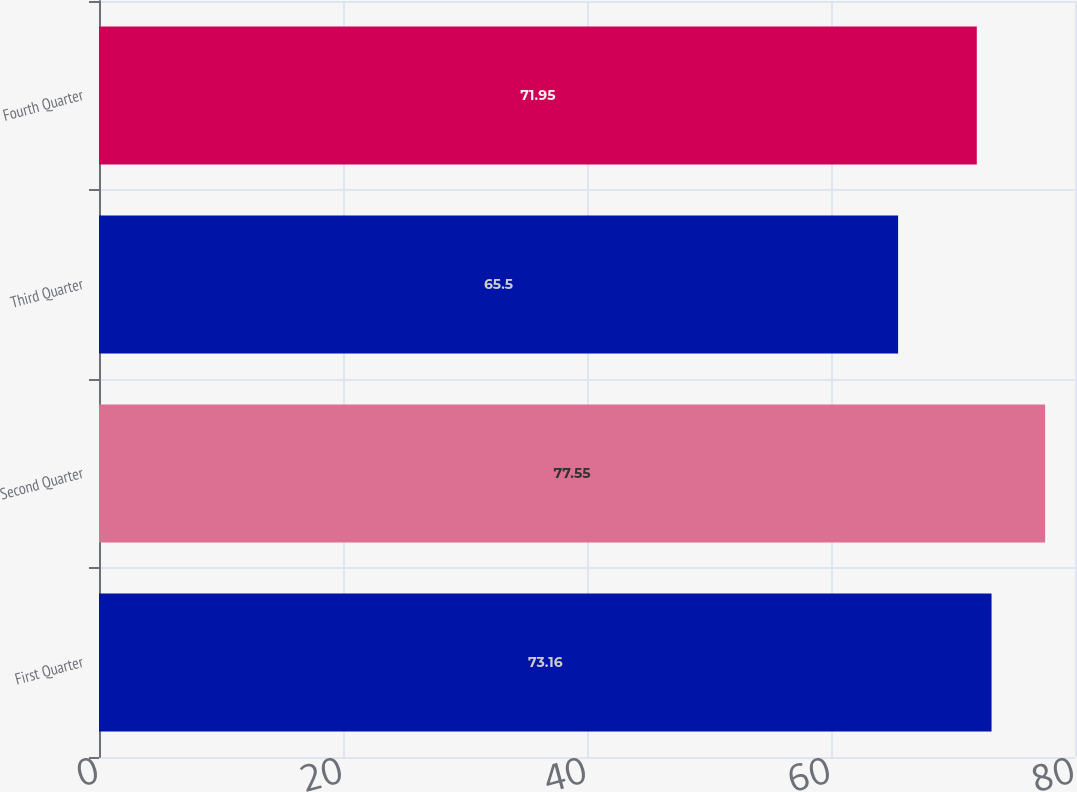Convert chart to OTSL. <chart><loc_0><loc_0><loc_500><loc_500><bar_chart><fcel>First Quarter<fcel>Second Quarter<fcel>Third Quarter<fcel>Fourth Quarter<nl><fcel>73.16<fcel>77.55<fcel>65.5<fcel>71.95<nl></chart> 